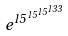Convert formula to latex. <formula><loc_0><loc_0><loc_500><loc_500>e ^ { 1 5 ^ { 1 5 ^ { 1 5 ^ { 1 3 3 } } } }</formula> 